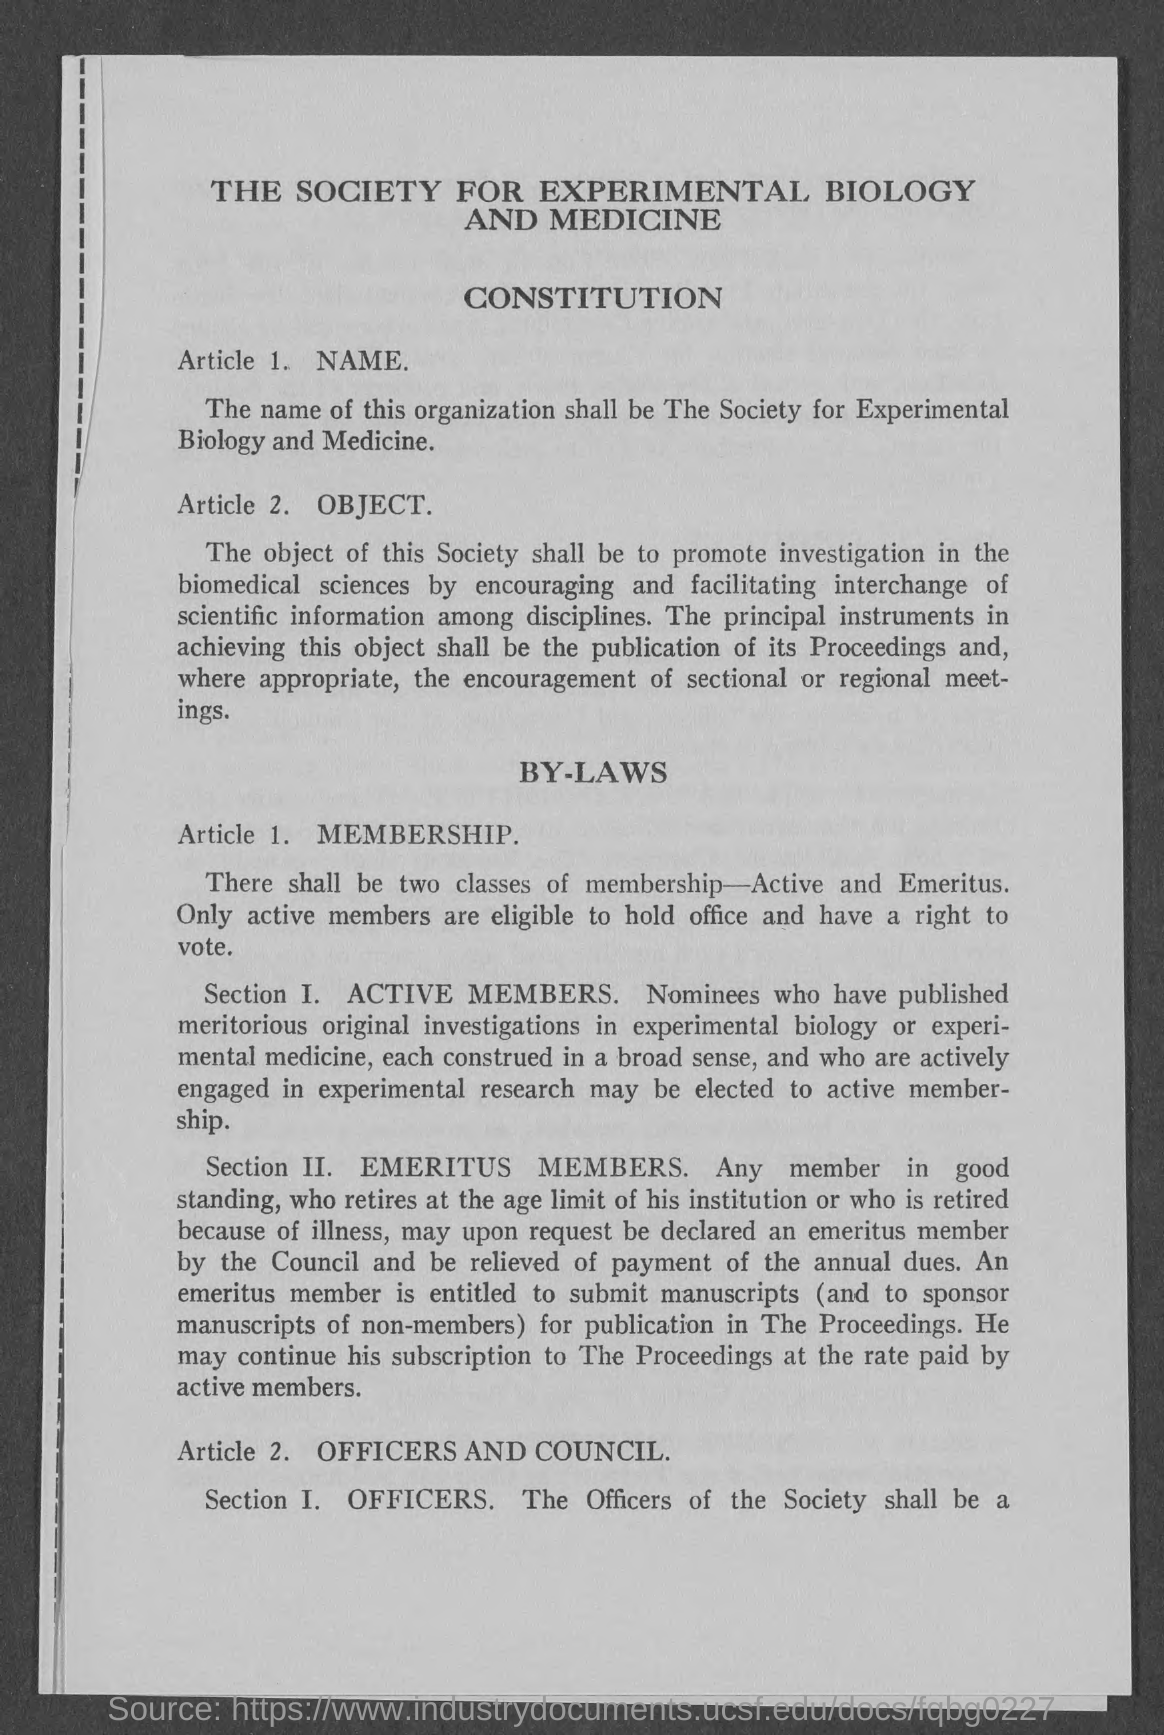Which society is mentioned?
Make the answer very short. The society for experimental biology and medicine. What are the two classes of membership?
Your response must be concise. Active and emeritus. Which members are eligible to hold office and vote?
Your response must be concise. Active. 